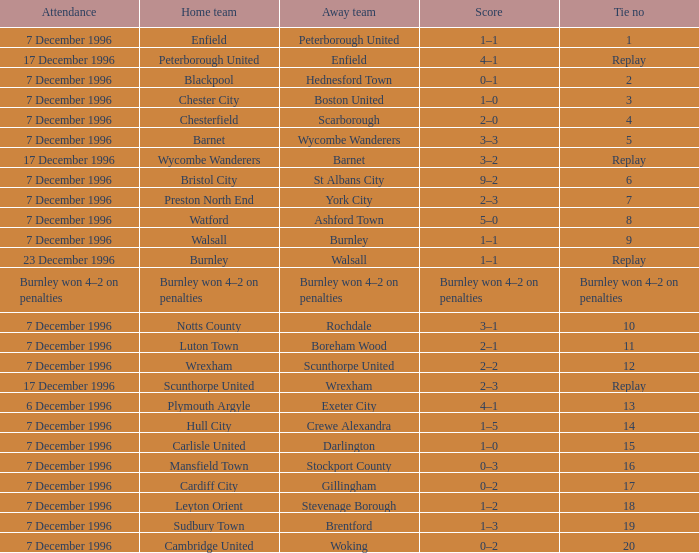What was the score of tie number 15? 1–0. 